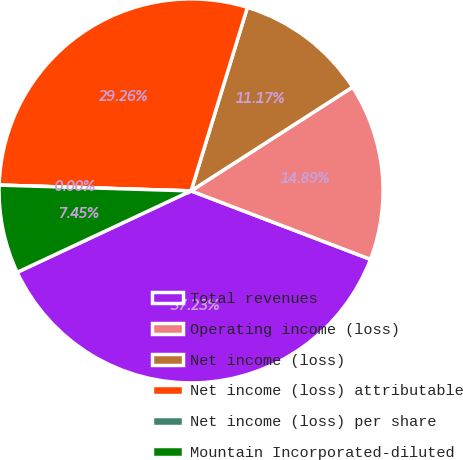<chart> <loc_0><loc_0><loc_500><loc_500><pie_chart><fcel>Total revenues<fcel>Operating income (loss)<fcel>Net income (loss)<fcel>Net income (loss) attributable<fcel>Net income (loss) per share<fcel>Mountain Incorporated-diluted<nl><fcel>37.23%<fcel>14.89%<fcel>11.17%<fcel>29.26%<fcel>0.0%<fcel>7.45%<nl></chart> 